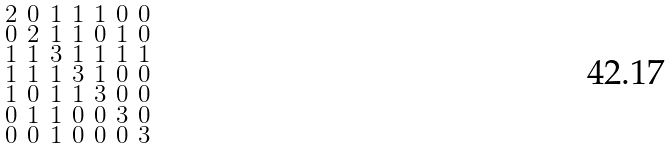<formula> <loc_0><loc_0><loc_500><loc_500>\begin{smallmatrix} 2 & 0 & 1 & 1 & 1 & 0 & 0 \\ 0 & 2 & 1 & 1 & 0 & 1 & 0 \\ 1 & 1 & 3 & 1 & 1 & 1 & 1 \\ 1 & 1 & 1 & 3 & 1 & 0 & 0 \\ 1 & 0 & 1 & 1 & 3 & 0 & 0 \\ 0 & 1 & 1 & 0 & 0 & 3 & 0 \\ 0 & 0 & 1 & 0 & 0 & 0 & 3 \end{smallmatrix}</formula> 